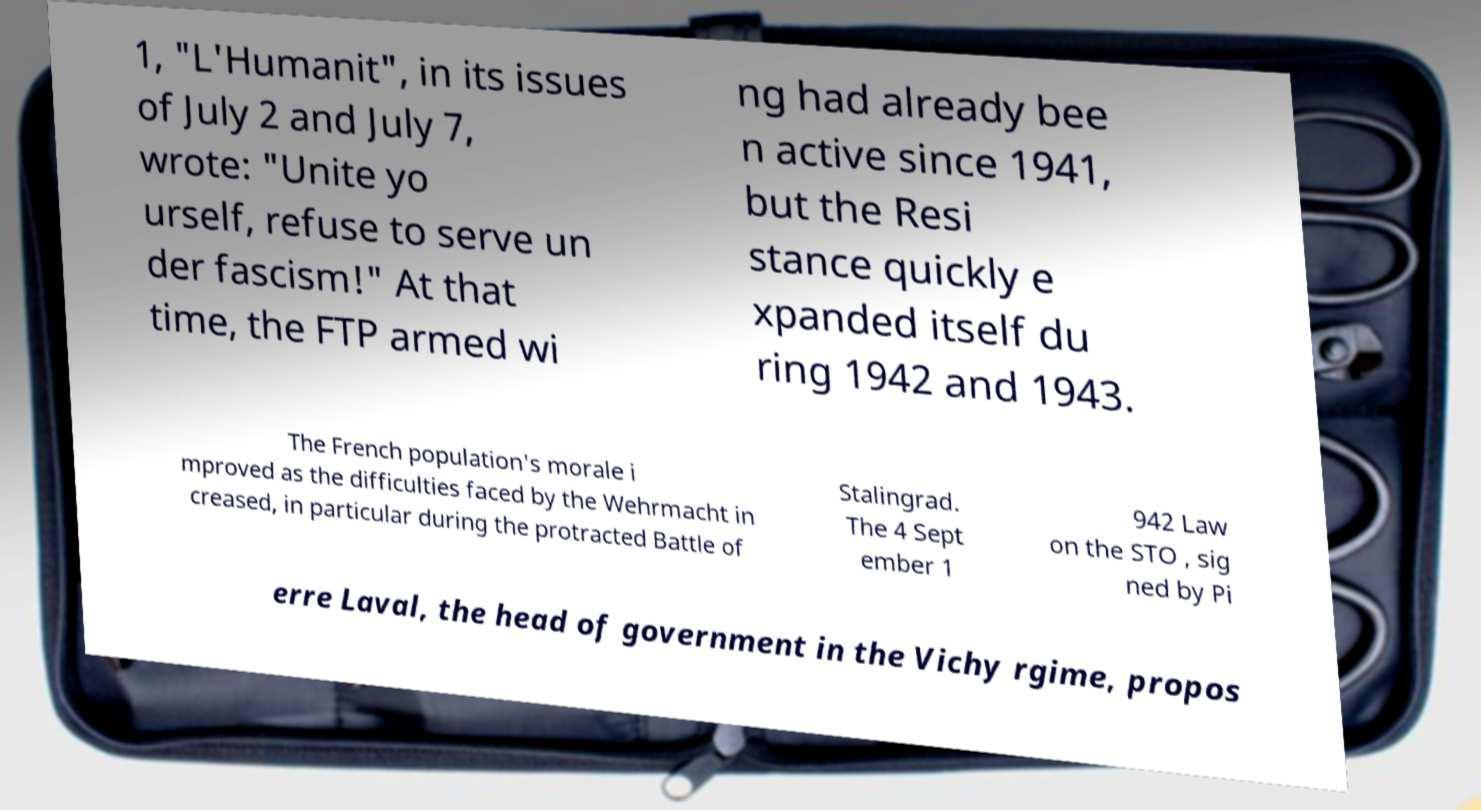Please read and relay the text visible in this image. What does it say? 1, "L'Humanit", in its issues of July 2 and July 7, wrote: "Unite yo urself, refuse to serve un der fascism!" At that time, the FTP armed wi ng had already bee n active since 1941, but the Resi stance quickly e xpanded itself du ring 1942 and 1943. The French population's morale i mproved as the difficulties faced by the Wehrmacht in creased, in particular during the protracted Battle of Stalingrad. The 4 Sept ember 1 942 Law on the STO , sig ned by Pi erre Laval, the head of government in the Vichy rgime, propos 